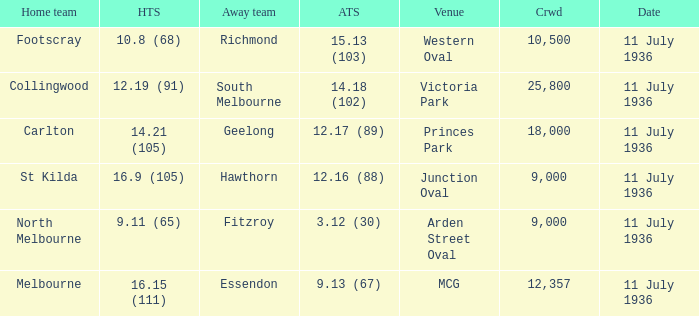What is the lowest crowd seen by the mcg Venue? 12357.0. 